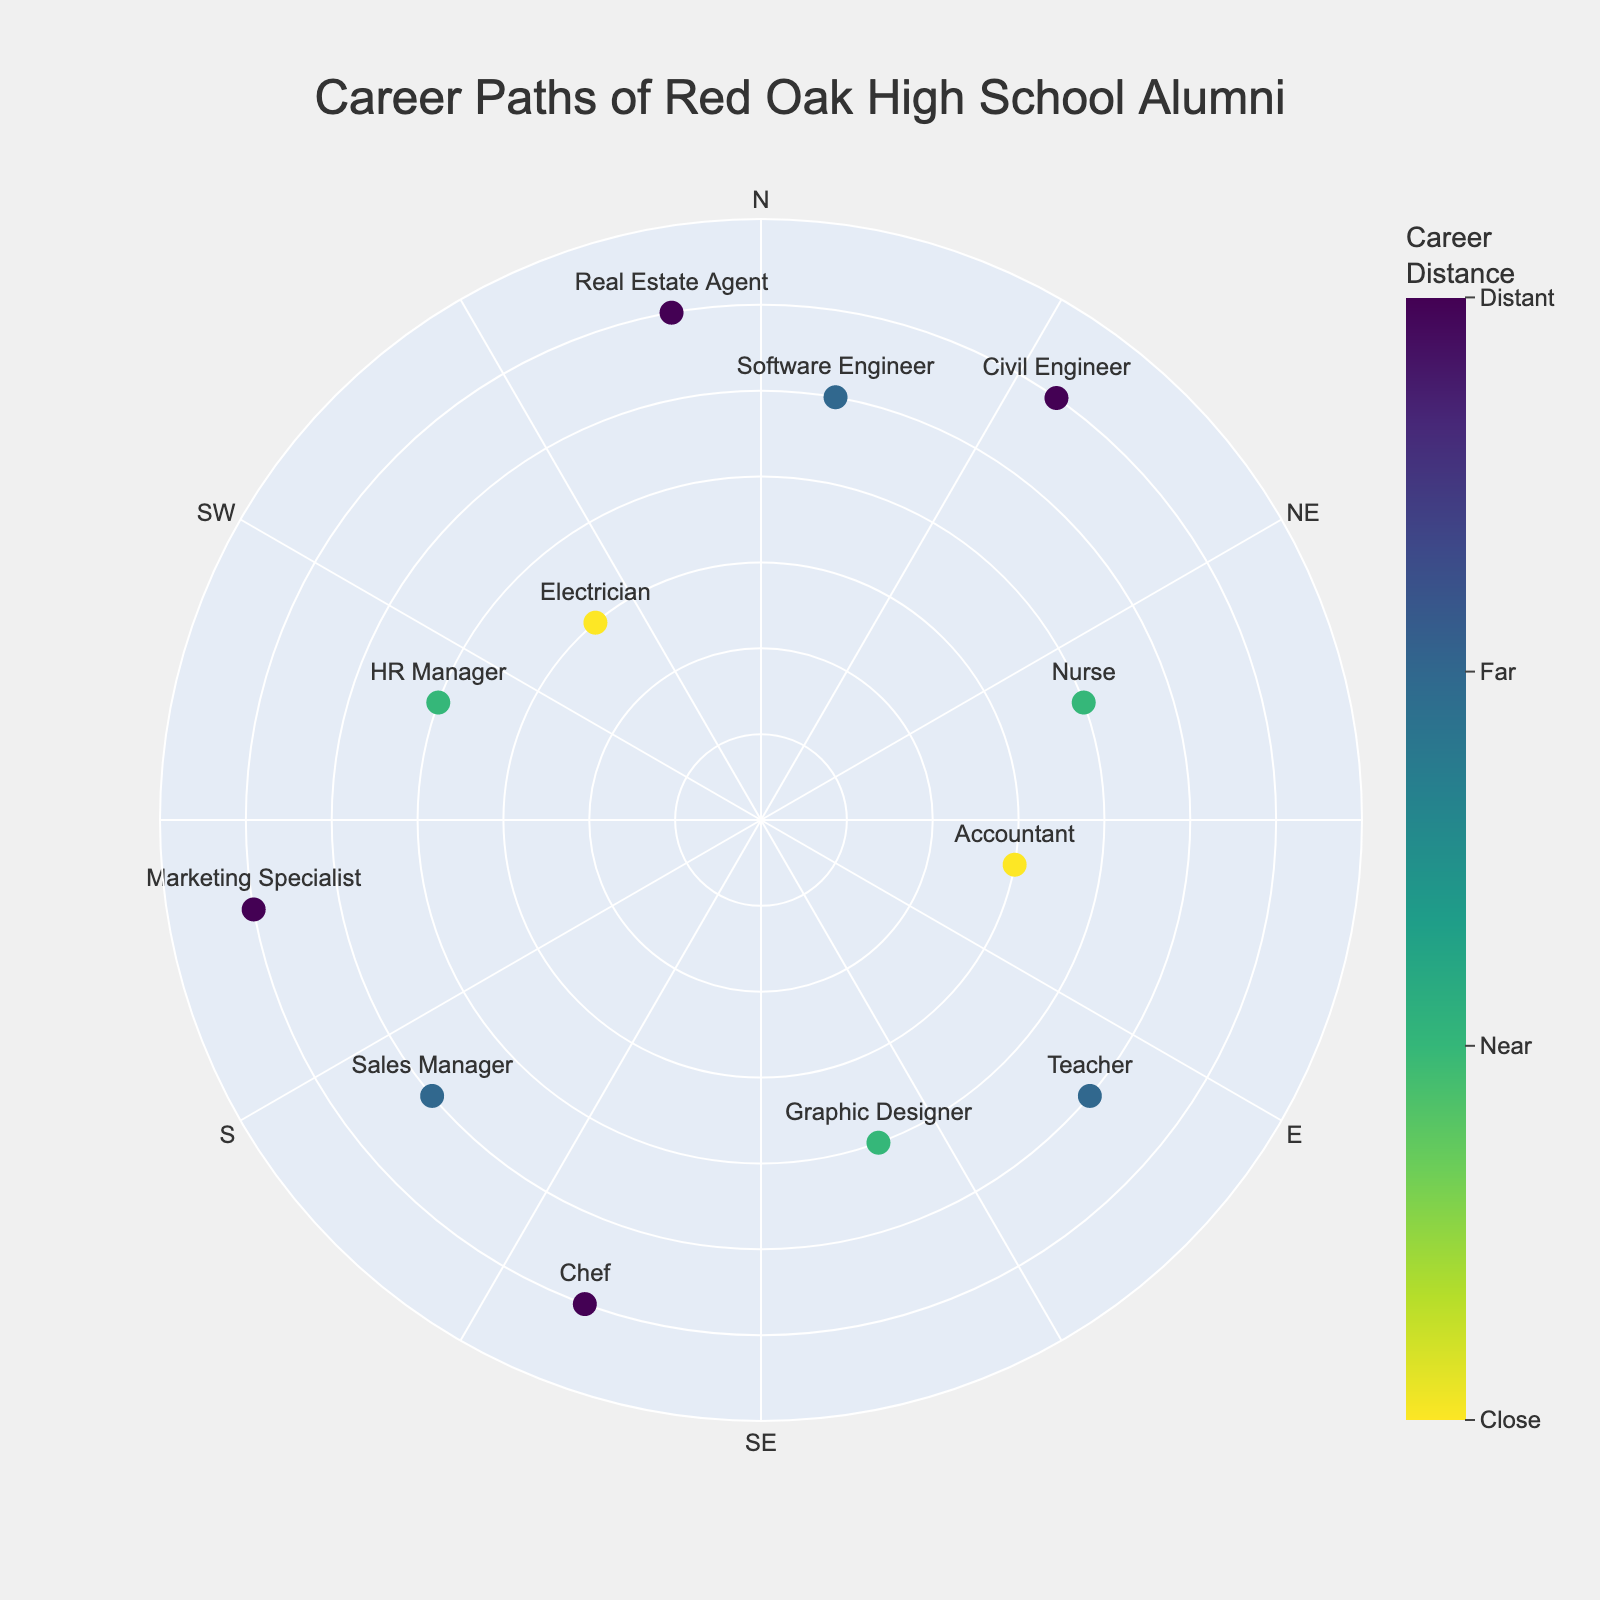How many data points are there in total? Count the number of markers on the scatter plot. Each marker represents a profession.
Answer: 12 Which profession is furthest from the center? Identify the profession with the highest 'Distance' value. The further the marker is from the center, the higher the distance.
Answer: Marketing Specialist What is the title of the chart? Look at the top of the chart where the title is typically located.
Answer: Career Paths of Red Oak High School Alumni Name two professions represented in the Healthcare and Technology industries. Identify the markers related to the Healthcare and Technology industries and read their labels.
Answer: Nurse, Software Engineer Which industry has the most 'distant' career paths? Observe the color bar and identify the color corresponding to 'Distant' (value 6). Then, see which industry labels appear at these points.
Answer: Construction, Hospitality, Marketing, Real Estate What is the range of the radial axis? Check the radial axis labeling and the values it covers to find the minimum and maximum.
Answer: 0 to 7 What are the angular axis tick intervals? Observe the angular axis and identify the numerical difference between consecutive tick marks.
Answer: 30 degrees Which profession has the closest 'Distance' value? Identify the profession with the lowest 'Distance' value, represented by markers closest to the center.
Answer: Electrician, Accountant Compare the Distance between a Teacher and a Civil Engineer. Which is greater? Locate the markers for Teacher and Civil Engineer, and compare the distances from the center.
Answer: Civil Engineer Describe the distribution of careers in trades vs. arts by distance. Observe the markers associated with 'Electrician' (Trades) and 'Graphic Designer' (Arts), and compare their distances from the center.
Answer: Electrician: close; Graphic Designer: near 